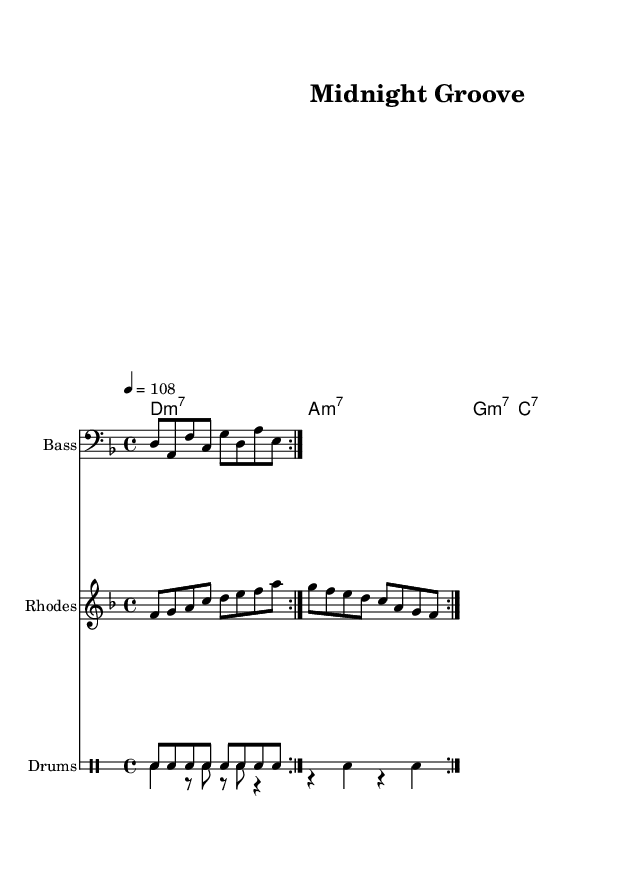What is the key signature of this music? The key signature is D minor, which has one flat (B flat). This can be identified by the sharp and flat symbols shown at the beginning of the staff.
Answer: D minor What is the time signature of this music? The time signature is 4/4, which indicates there are four beats in each measure and the quarter note receives one beat. This is shown at the start of the score.
Answer: 4/4 What tempo marking is indicated? The tempo marking indicates 108 beats per minute, like the text "4 = 108" in the score, which specifies the speed at which the piece should be played.
Answer: 108 How many measures are repeated in the bass line? The bass line has two repeated measures, evident from the "repeat volta 2" notation that indicates this section is to be played twice.
Answer: 2 What type of chords are used for the guitar? The guitar chords consist of minor seventh and dominant seventh chords, which is specified by the chord symbols "m7" and "7" in the chord mode section.
Answer: Minor seventh and dominant seventh How do the bass line and rhodes melody relate in instrumentation? The bass line is played in a lower register on the bass staff while the Rhodes melody is in a higher register on the treble staff, showing the contrasting usage of lower and upper instrumental ranges.
Answer: Contrasting registers What is the function of the drum pattern in this piece? The drum pattern provides a steady rhythmic foundation, creating a groove essential in funk music. The hi-hats keep a consistent pulse while the bass drum adds accents, illustrating the active role of percussion in maintaining rhythm.
Answer: Rhythmic foundation 